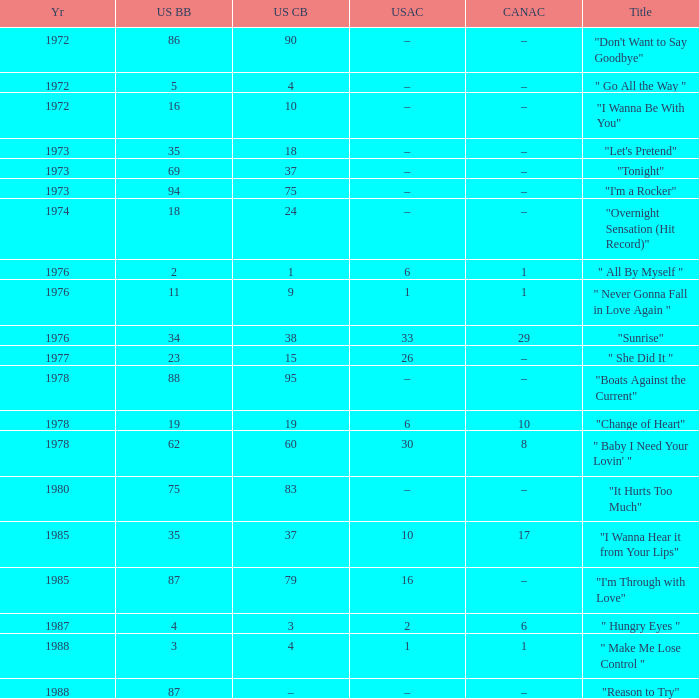What is the US cash box before 1978 with a US billboard of 35? 18.0. 